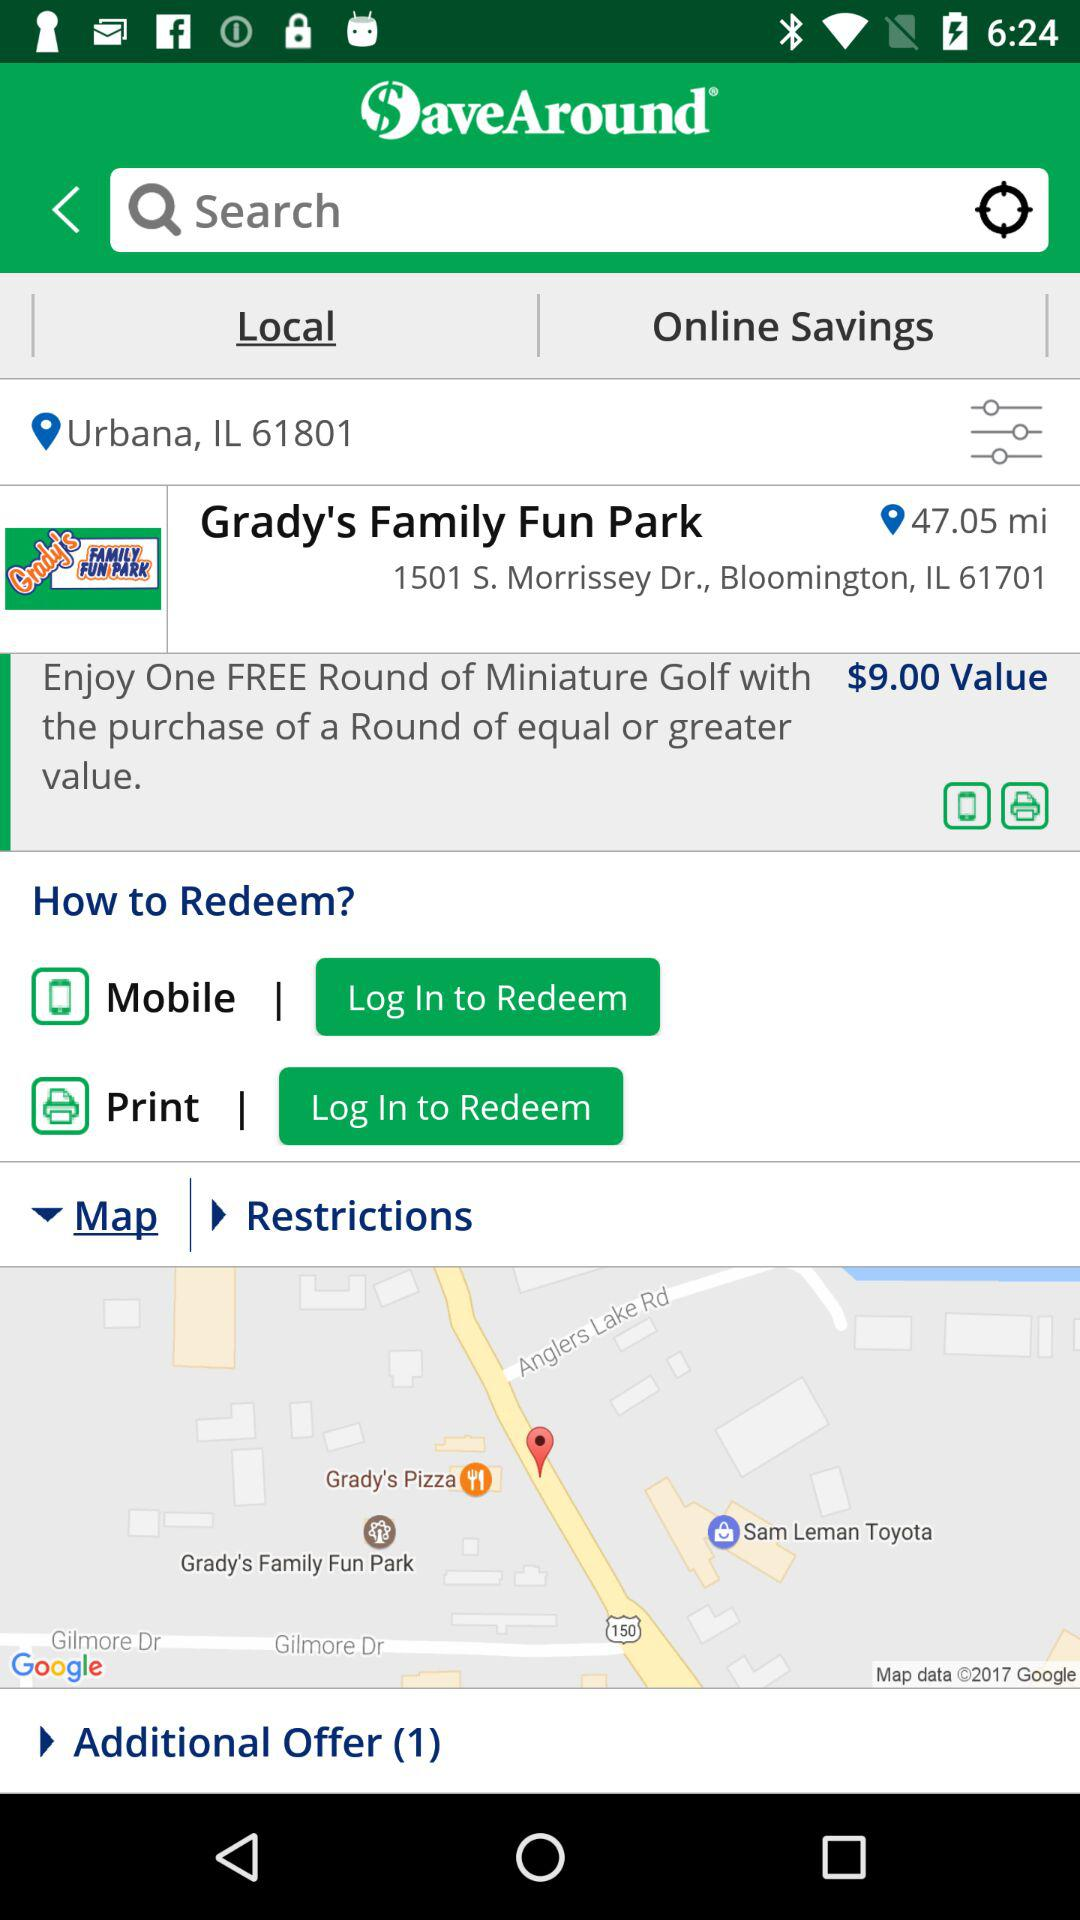What is the pin code of the park? The pin code is 61701. 